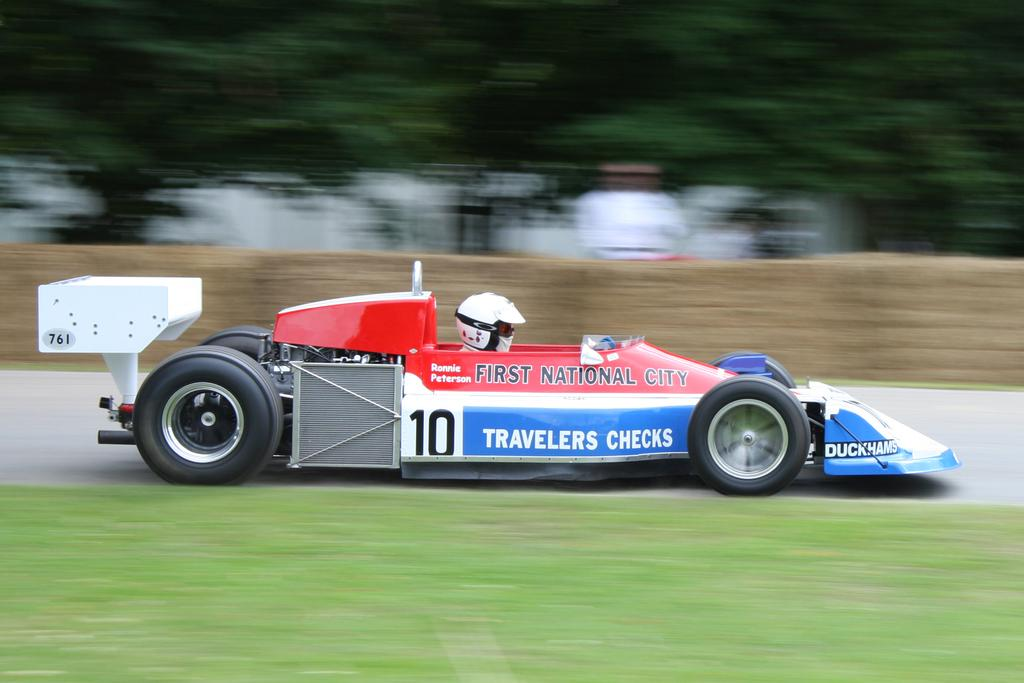What is the main subject of the image? The main subject of the image is a vehicle. What colors are visible on the vehicle? The vehicle has red, white, and blue colors. Can you describe the person inside the vehicle? There is a person sitting inside the vehicle, and they are wearing a helmet. What can be observed about the background of the image? The background of the image is blurred. How many kisses can be seen on the dirt in the image? There is no dirt or kisses present in the image; it features a vehicle with a person wearing a helmet and a blurred background. 